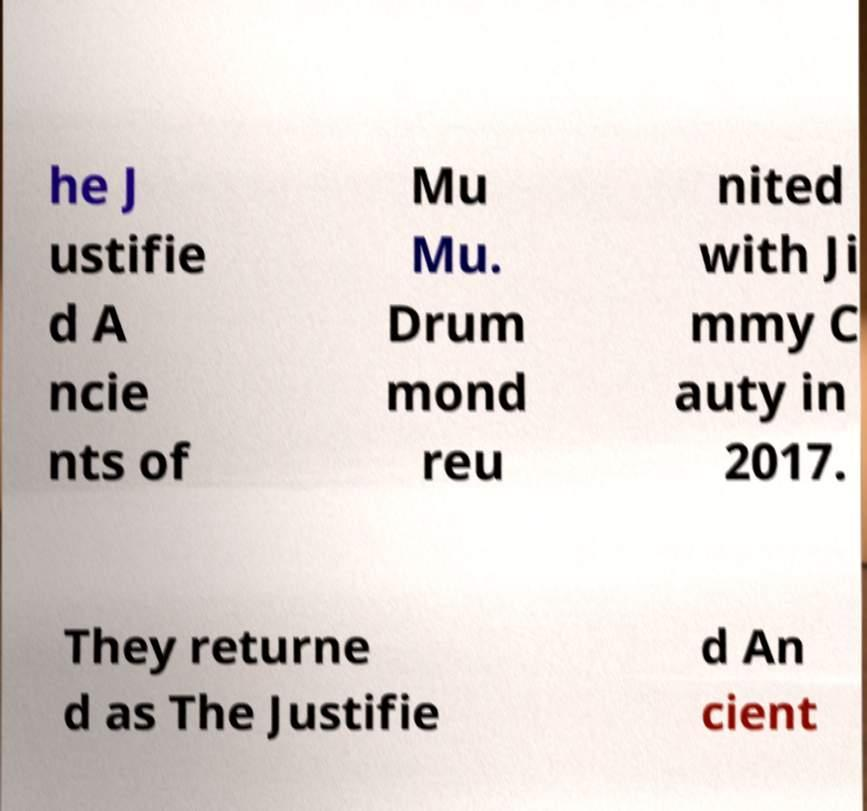What messages or text are displayed in this image? I need them in a readable, typed format. he J ustifie d A ncie nts of Mu Mu. Drum mond reu nited with Ji mmy C auty in 2017. They returne d as The Justifie d An cient 